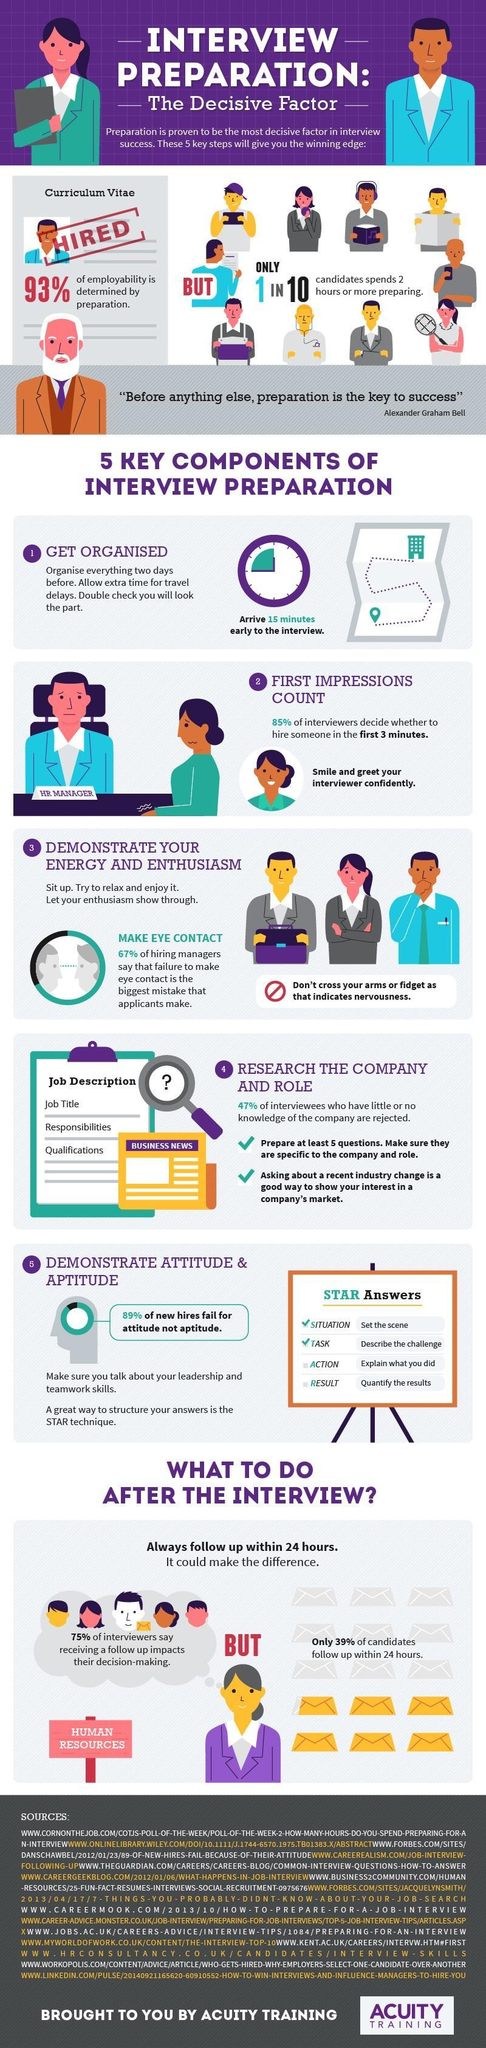What percentage of hiring managers do not agree that eye contact is important?
Answer the question with a short phrase. 33% What percentage of interviewees fail because of their aptitude? 11% 